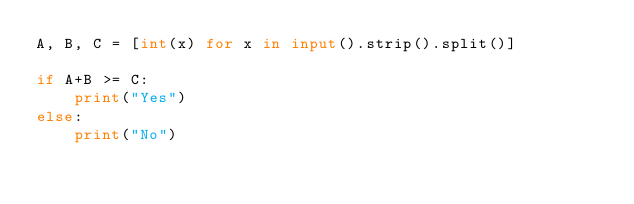<code> <loc_0><loc_0><loc_500><loc_500><_Python_>A, B, C = [int(x) for x in input().strip().split()]

if A+B >= C:
    print("Yes")
else:
    print("No")</code> 